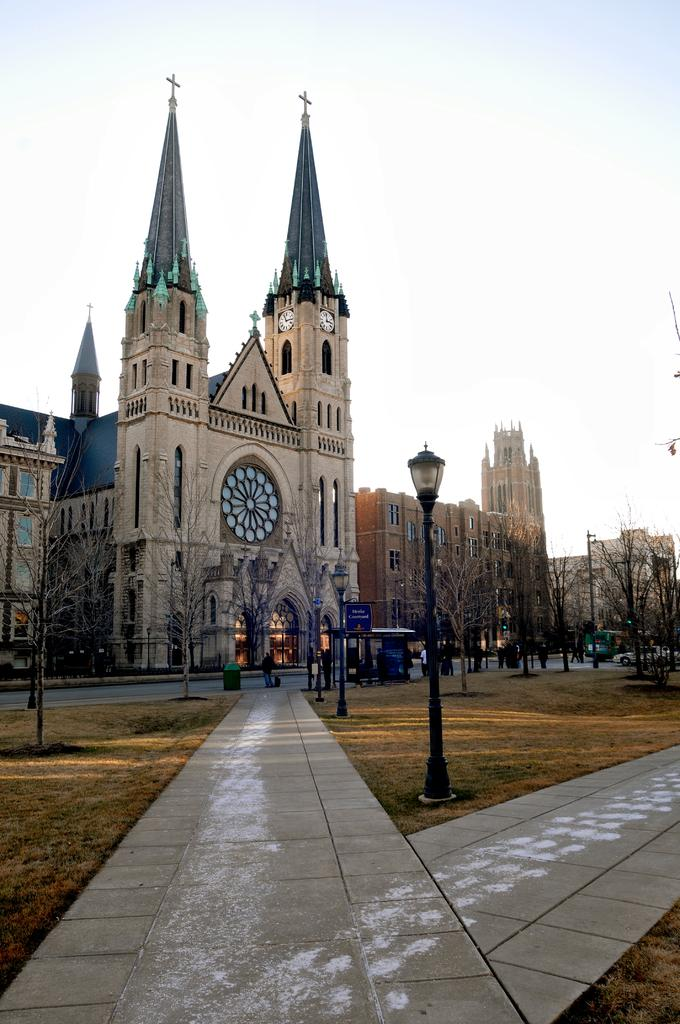What can be seen in the center of the image? The sky is visible in the center of the image. What type of structures are present in the image? There are buildings in the image. What other natural elements can be seen in the image? Trees are present in the image. What man-made objects are visible in the image? Poles are visible in the image. What type of transportation is in the image? Vehicles are in the image. Are there any living beings in the image? Yes, there are people in the image. Can you describe any other objects in the image? There are a few other objects in the image. What type of weather can be seen in the mouth of the person in the image? There is no person with a mouth visible in the image, and therefore no weather can be seen in it. 